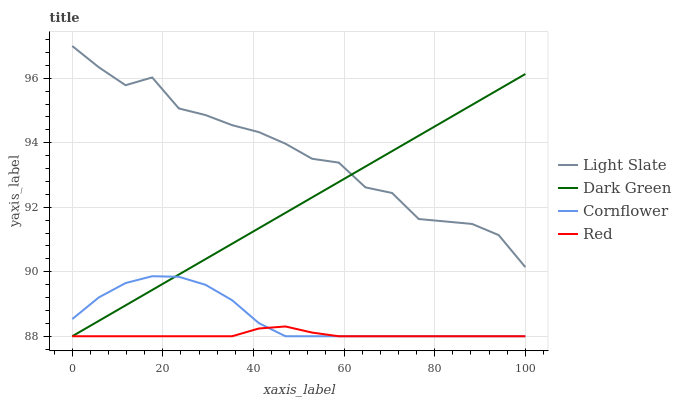Does Cornflower have the minimum area under the curve?
Answer yes or no. No. Does Cornflower have the maximum area under the curve?
Answer yes or no. No. Is Cornflower the smoothest?
Answer yes or no. No. Is Cornflower the roughest?
Answer yes or no. No. Does Cornflower have the highest value?
Answer yes or no. No. Is Red less than Light Slate?
Answer yes or no. Yes. Is Light Slate greater than Cornflower?
Answer yes or no. Yes. Does Red intersect Light Slate?
Answer yes or no. No. 